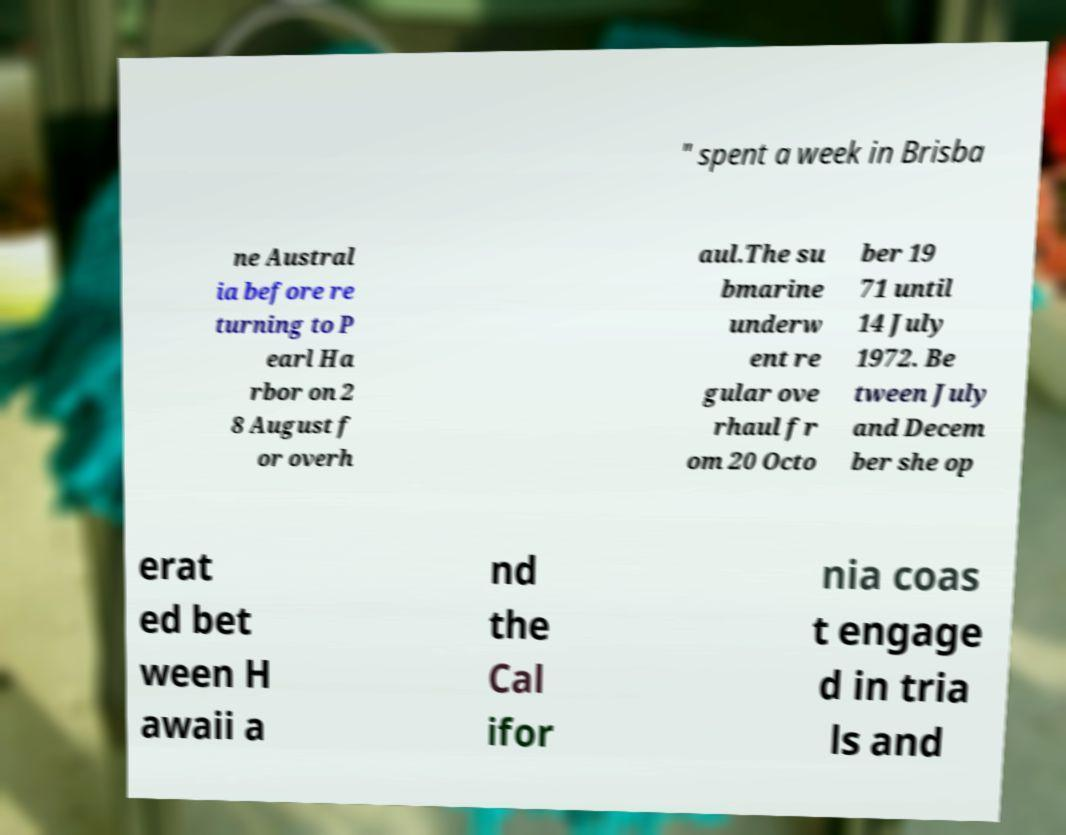Could you extract and type out the text from this image? " spent a week in Brisba ne Austral ia before re turning to P earl Ha rbor on 2 8 August f or overh aul.The su bmarine underw ent re gular ove rhaul fr om 20 Octo ber 19 71 until 14 July 1972. Be tween July and Decem ber she op erat ed bet ween H awaii a nd the Cal ifor nia coas t engage d in tria ls and 